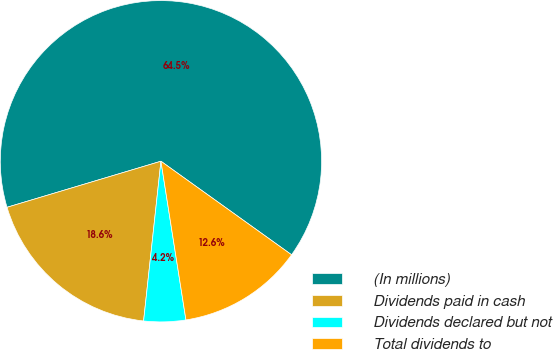<chart> <loc_0><loc_0><loc_500><loc_500><pie_chart><fcel>(In millions)<fcel>Dividends paid in cash<fcel>Dividends declared but not<fcel>Total dividends to<nl><fcel>64.52%<fcel>18.65%<fcel>4.21%<fcel>12.62%<nl></chart> 